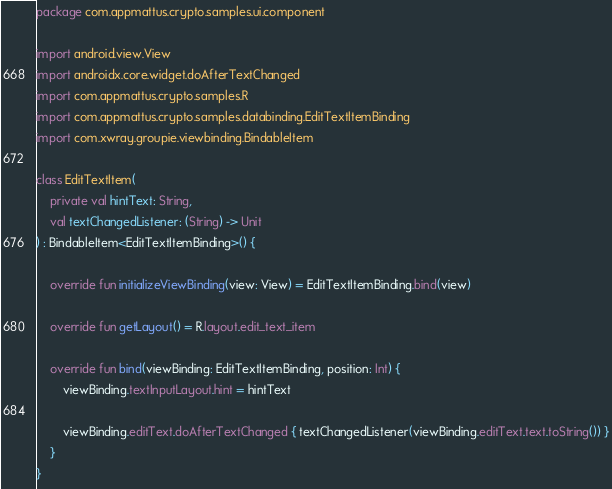Convert code to text. <code><loc_0><loc_0><loc_500><loc_500><_Kotlin_>package com.appmattus.crypto.samples.ui.component

import android.view.View
import androidx.core.widget.doAfterTextChanged
import com.appmattus.crypto.samples.R
import com.appmattus.crypto.samples.databinding.EditTextItemBinding
import com.xwray.groupie.viewbinding.BindableItem

class EditTextItem(
    private val hintText: String,
    val textChangedListener: (String) -> Unit
) : BindableItem<EditTextItemBinding>() {

    override fun initializeViewBinding(view: View) = EditTextItemBinding.bind(view)

    override fun getLayout() = R.layout.edit_text_item

    override fun bind(viewBinding: EditTextItemBinding, position: Int) {
        viewBinding.textInputLayout.hint = hintText

        viewBinding.editText.doAfterTextChanged { textChangedListener(viewBinding.editText.text.toString()) }
    }
}
</code> 